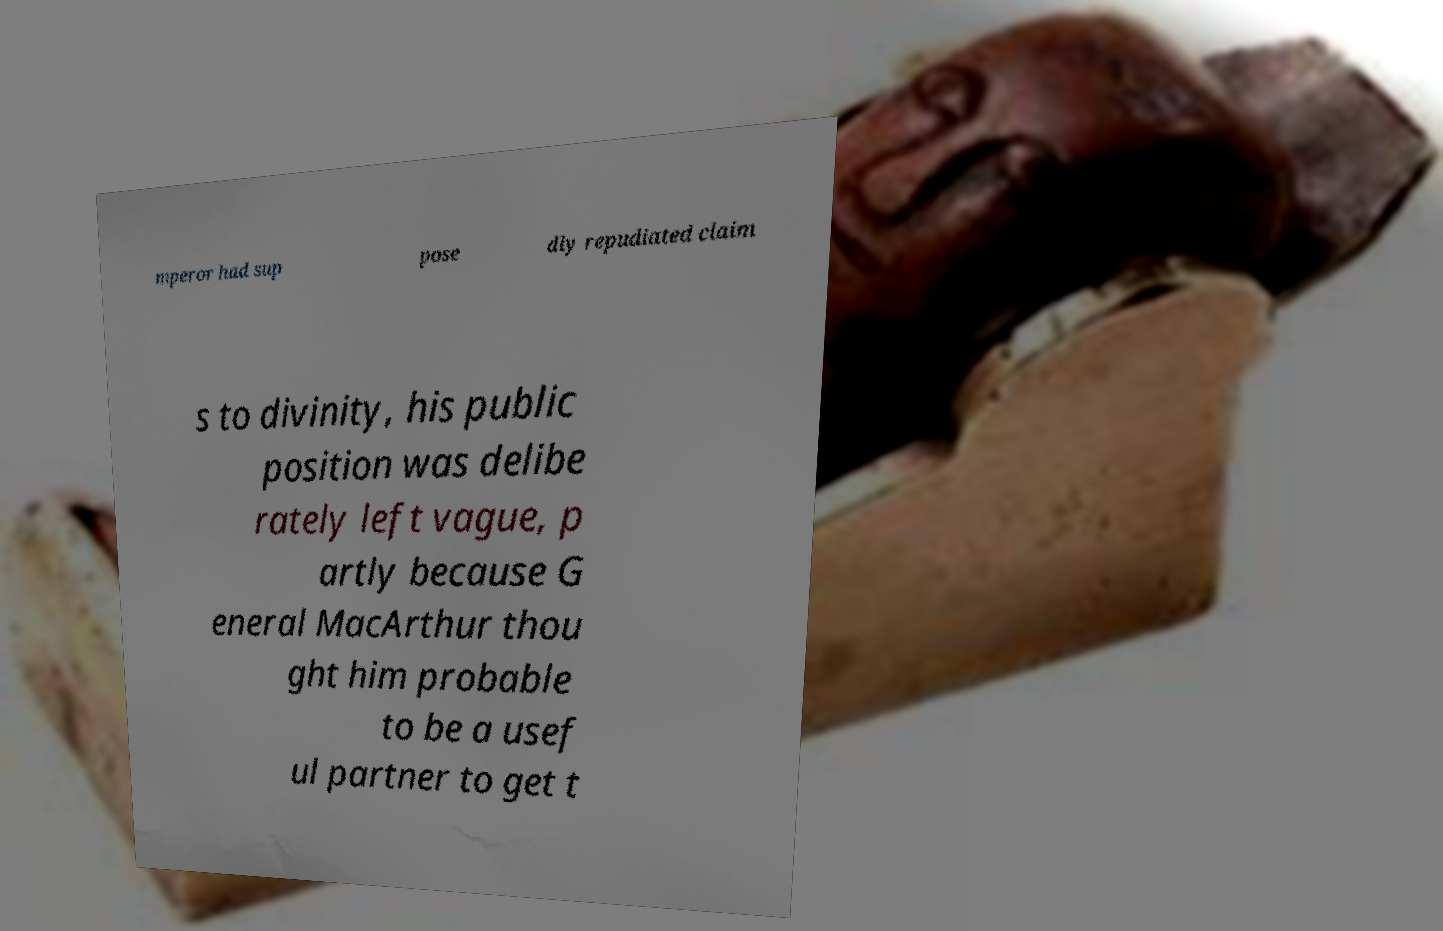Please identify and transcribe the text found in this image. mperor had sup pose dly repudiated claim s to divinity, his public position was delibe rately left vague, p artly because G eneral MacArthur thou ght him probable to be a usef ul partner to get t 